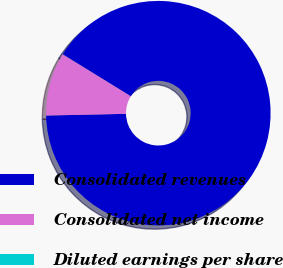<chart> <loc_0><loc_0><loc_500><loc_500><pie_chart><fcel>Consolidated revenues<fcel>Consolidated net income<fcel>Diluted earnings per share<nl><fcel>90.89%<fcel>9.1%<fcel>0.01%<nl></chart> 